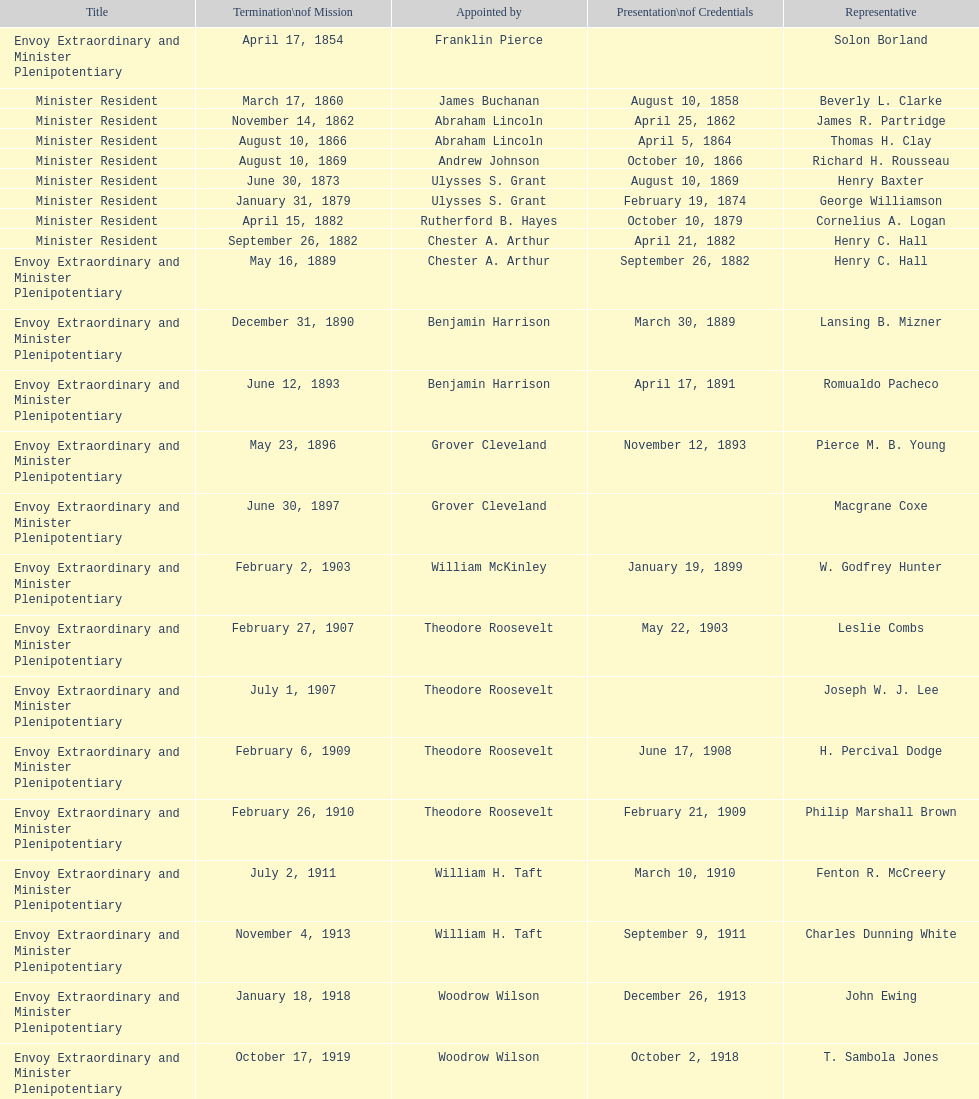How many total representatives have there been? 50. Can you parse all the data within this table? {'header': ['Title', 'Termination\\nof Mission', 'Appointed by', 'Presentation\\nof Credentials', 'Representative'], 'rows': [['Envoy Extraordinary and Minister Plenipotentiary', 'April 17, 1854', 'Franklin Pierce', '', 'Solon Borland'], ['Minister Resident', 'March 17, 1860', 'James Buchanan', 'August 10, 1858', 'Beverly L. Clarke'], ['Minister Resident', 'November 14, 1862', 'Abraham Lincoln', 'April 25, 1862', 'James R. Partridge'], ['Minister Resident', 'August 10, 1866', 'Abraham Lincoln', 'April 5, 1864', 'Thomas H. Clay'], ['Minister Resident', 'August 10, 1869', 'Andrew Johnson', 'October 10, 1866', 'Richard H. Rousseau'], ['Minister Resident', 'June 30, 1873', 'Ulysses S. Grant', 'August 10, 1869', 'Henry Baxter'], ['Minister Resident', 'January 31, 1879', 'Ulysses S. Grant', 'February 19, 1874', 'George Williamson'], ['Minister Resident', 'April 15, 1882', 'Rutherford B. Hayes', 'October 10, 1879', 'Cornelius A. Logan'], ['Minister Resident', 'September 26, 1882', 'Chester A. Arthur', 'April 21, 1882', 'Henry C. Hall'], ['Envoy Extraordinary and Minister Plenipotentiary', 'May 16, 1889', 'Chester A. Arthur', 'September 26, 1882', 'Henry C. Hall'], ['Envoy Extraordinary and Minister Plenipotentiary', 'December 31, 1890', 'Benjamin Harrison', 'March 30, 1889', 'Lansing B. Mizner'], ['Envoy Extraordinary and Minister Plenipotentiary', 'June 12, 1893', 'Benjamin Harrison', 'April 17, 1891', 'Romualdo Pacheco'], ['Envoy Extraordinary and Minister Plenipotentiary', 'May 23, 1896', 'Grover Cleveland', 'November 12, 1893', 'Pierce M. B. Young'], ['Envoy Extraordinary and Minister Plenipotentiary', 'June 30, 1897', 'Grover Cleveland', '', 'Macgrane Coxe'], ['Envoy Extraordinary and Minister Plenipotentiary', 'February 2, 1903', 'William McKinley', 'January 19, 1899', 'W. Godfrey Hunter'], ['Envoy Extraordinary and Minister Plenipotentiary', 'February 27, 1907', 'Theodore Roosevelt', 'May 22, 1903', 'Leslie Combs'], ['Envoy Extraordinary and Minister Plenipotentiary', 'July 1, 1907', 'Theodore Roosevelt', '', 'Joseph W. J. Lee'], ['Envoy Extraordinary and Minister Plenipotentiary', 'February 6, 1909', 'Theodore Roosevelt', 'June 17, 1908', 'H. Percival Dodge'], ['Envoy Extraordinary and Minister Plenipotentiary', 'February 26, 1910', 'Theodore Roosevelt', 'February 21, 1909', 'Philip Marshall Brown'], ['Envoy Extraordinary and Minister Plenipotentiary', 'July 2, 1911', 'William H. Taft', 'March 10, 1910', 'Fenton R. McCreery'], ['Envoy Extraordinary and Minister Plenipotentiary', 'November 4, 1913', 'William H. Taft', 'September 9, 1911', 'Charles Dunning White'], ['Envoy Extraordinary and Minister Plenipotentiary', 'January 18, 1918', 'Woodrow Wilson', 'December 26, 1913', 'John Ewing'], ['Envoy Extraordinary and Minister Plenipotentiary', 'October 17, 1919', 'Woodrow Wilson', 'October 2, 1918', 'T. Sambola Jones'], ['Envoy Extraordinary and Minister Plenipotentiary', 'March 2, 1925', 'Warren G. Harding', 'January 18, 1922', 'Franklin E. Morales'], ['Envoy Extraordinary and Minister Plenipotentiary', 'December 17, 1929', 'Calvin Coolidge', 'November 21, 1925', 'George T. Summerlin'], ['Envoy Extraordinary and Minister Plenipotentiary', 'March 17, 1935', 'Herbert Hoover', 'May 31, 1930', 'Julius G. Lay'], ['Envoy Extraordinary and Minister Plenipotentiary', 'May 1, 1937', 'Franklin D. Roosevelt', 'July 19, 1935', 'Leo J. Keena'], ['Envoy Extraordinary and Minister Plenipotentiary', 'April 27, 1943', 'Franklin D. Roosevelt', 'September 8, 1937', 'John Draper Erwin'], ['Ambassador Extraordinary and Plenipotentiary', 'April 16, 1947', 'Franklin D. Roosevelt', 'April 27, 1943', 'John Draper Erwin'], ['Ambassador Extraordinary and Plenipotentiary', 'October 30, 1947', 'Harry S. Truman', 'June 23, 1947', 'Paul C. Daniels'], ['Ambassador Extraordinary and Plenipotentiary', 'December 12, 1950', 'Harry S. Truman', 'May 15, 1948', 'Herbert S. Bursley'], ['Ambassador Extraordinary and Plenipotentiary', 'February 28, 1954', 'Harry S. Truman', 'March 14, 1951', 'John Draper Erwin'], ['Ambassador Extraordinary and Plenipotentiary', 'March 24, 1958', 'Dwight D. Eisenhower', 'March 5, 1954', 'Whiting Willauer'], ['Ambassador Extraordinary and Plenipotentiary', 'August 3, 1960', 'Dwight D. Eisenhower', 'April 30, 1958', 'Robert Newbegin'], ['Ambassador Extraordinary and Plenipotentiary', 'June 28, 1965', 'Dwight D. Eisenhower', 'November 3, 1960', 'Charles R. Burrows'], ['Ambassador Extraordinary and Plenipotentiary', 'June 21, 1969', 'Lyndon B. Johnson', 'July 12, 1965', 'Joseph J. Jova'], ['Ambassador Extraordinary and Plenipotentiary', 'May 30, 1973', 'Richard Nixon', 'November 5, 1969', 'Hewson A. Ryan'], ['Ambassador Extraordinary and Plenipotentiary', 'July 17, 1976', 'Richard Nixon', 'June 15, 1973', 'Phillip V. Sanchez'], ['Ambassador Extraordinary and Plenipotentiary', 'August 1, 1977', 'Gerald Ford', 'October 27, 1976', 'Ralph E. Becker'], ['Ambassador Extraordinary and Plenipotentiary', 'September 19, 1980', 'Jimmy Carter', 'October 27, 1977', 'Mari-Luci Jaramillo'], ['Ambassador Extraordinary and Plenipotentiary', 'October 31, 1981', 'Jimmy Carter', 'October 10, 1980', 'Jack R. Binns'], ['Ambassador Extraordinary and Plenipotentiary', 'May 30, 1985', 'Ronald Reagan', 'November 11, 1981', 'John D. Negroponte'], ['Ambassador Extraordinary and Plenipotentiary', 'July 9, 1986', 'Ronald Reagan', 'August 22, 1985', 'John Arthur Ferch'], ['Ambassador Extraordinary and Plenipotentiary', 'June 15, 1989', 'Ronald Reagan', 'November 4, 1986', 'Everett Ellis Briggs'], ['Ambassador Extraordinary and Plenipotentiary', 'July 1, 1993', 'George H. W. Bush', 'January 29, 1990', 'Cresencio S. Arcos, Jr.'], ['Ambassador Extraordinary and Plenipotentiary', 'August 15, 1996', 'Bill Clinton', 'July 21, 1993', 'William Thornton Pryce'], ['Ambassador Extraordinary and Plenipotentiary', 'July 20, 1999', 'Bill Clinton', 'August 29, 1996', 'James F. Creagan'], ['Ambassador Extraordinary and Plenipotentiary', 'September 5, 2002', 'Bill Clinton', 'August 25, 1999', 'Frank Almaguer'], ['Ambassador Extraordinary and Plenipotentiary', 'May 7, 2005', 'George W. Bush', 'October 8, 2002', 'Larry Leon Palmer'], ['Ambassador Extraordinary and Plenipotentiary', 'ca. April 2008', 'George W. Bush', 'November 8, 2005', 'Charles A. Ford'], ['Ambassador Extraordinary and Plenipotentiary', 'ca. July 2011', 'George W. Bush', 'September 19, 2008', 'Hugo Llorens'], ['Ambassador Extraordinary and Plenipotentiary', 'Incumbent', 'Barack Obama', 'July 26, 2011', 'Lisa Kubiske']]} 